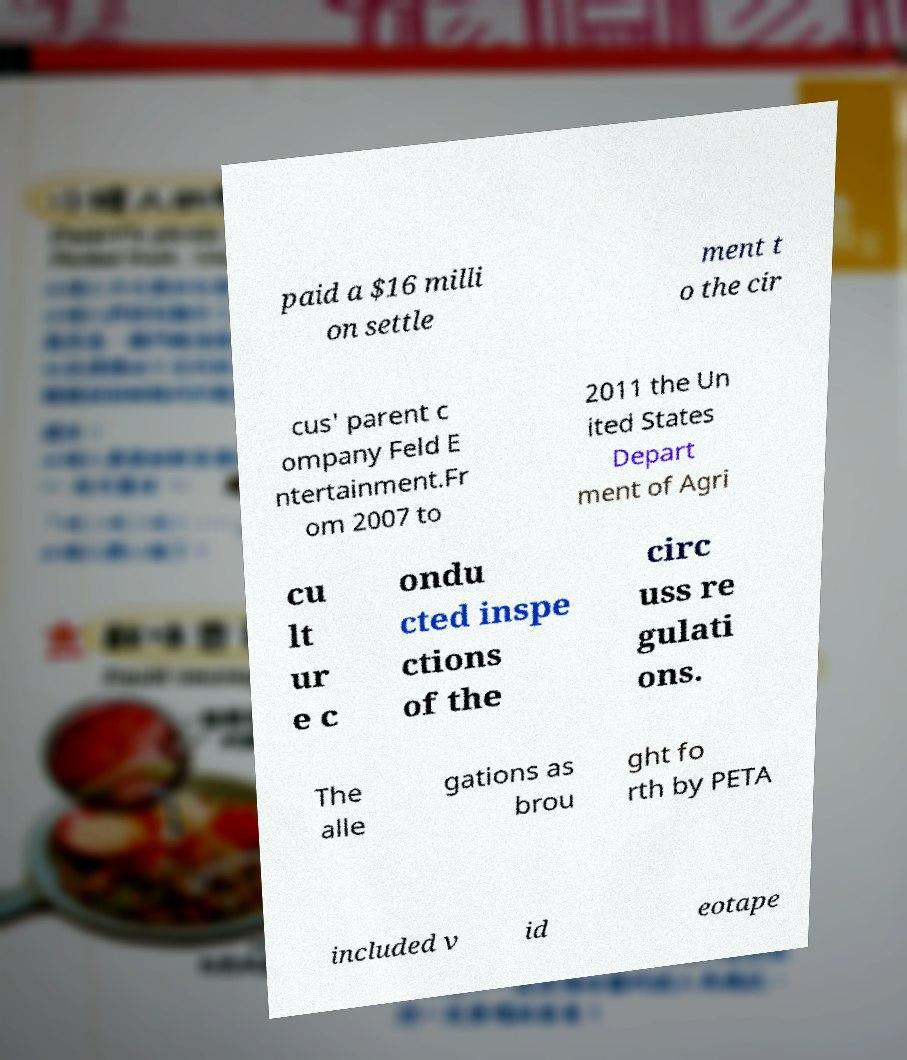Could you assist in decoding the text presented in this image and type it out clearly? paid a $16 milli on settle ment t o the cir cus' parent c ompany Feld E ntertainment.Fr om 2007 to 2011 the Un ited States Depart ment of Agri cu lt ur e c ondu cted inspe ctions of the circ uss re gulati ons. The alle gations as brou ght fo rth by PETA included v id eotape 